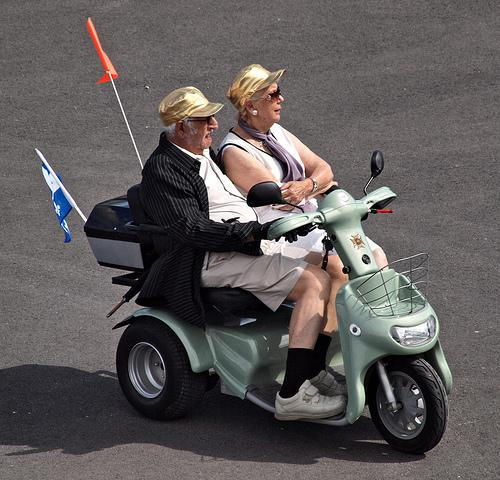Question: who is on the motor scooter?
Choices:
A. Three people.
B. Couple.
C. One person.
D. Noone.
Answer with the letter. Answer: B Question: what color are the hats?
Choices:
A. Blue.
B. Black.
C. Gold.
D. White.
Answer with the letter. Answer: C Question: how many people are shown?
Choices:
A. 1.
B. 3.
C. 4.
D. 2.
Answer with the letter. Answer: D Question: where is the basket?
Choices:
A. On the bike.
B. On the car.
C. On scooter.
D. On the sidewalk.
Answer with the letter. Answer: C 